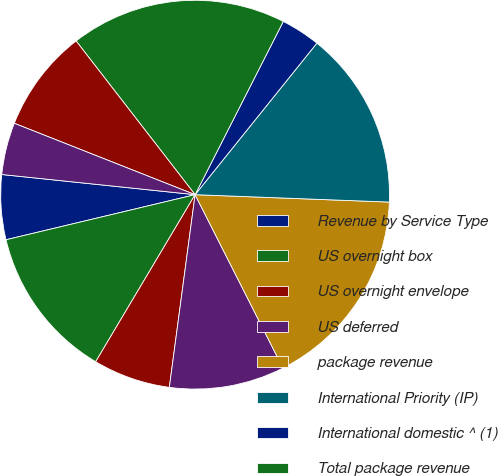<chart> <loc_0><loc_0><loc_500><loc_500><pie_chart><fcel>Revenue by Service Type<fcel>US overnight box<fcel>US overnight envelope<fcel>US deferred<fcel>package revenue<fcel>International Priority (IP)<fcel>International domestic ^ (1)<fcel>Total package revenue<fcel>US<fcel>International Priority Freight<nl><fcel>5.38%<fcel>12.73%<fcel>6.43%<fcel>9.58%<fcel>16.93%<fcel>14.83%<fcel>3.28%<fcel>17.98%<fcel>8.53%<fcel>4.33%<nl></chart> 